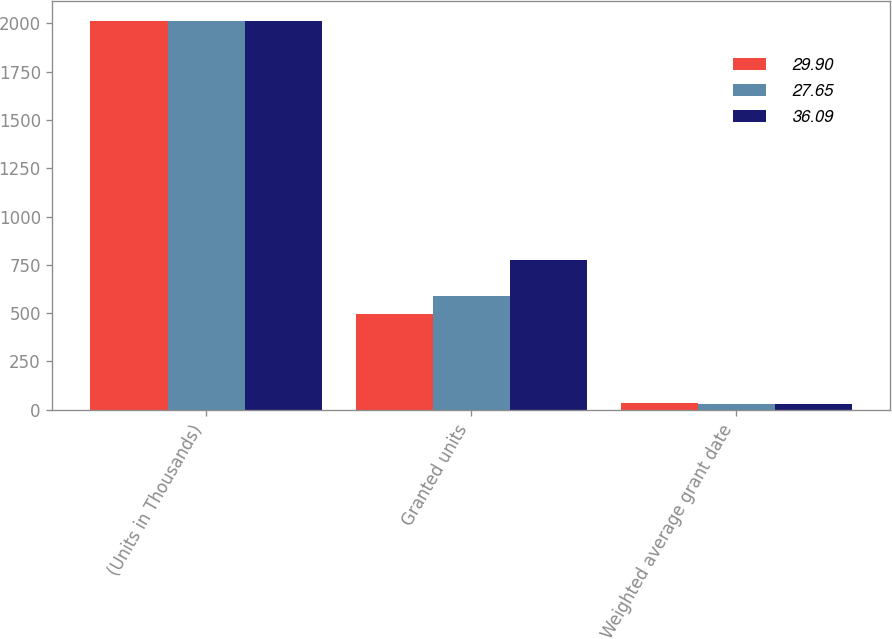Convert chart. <chart><loc_0><loc_0><loc_500><loc_500><stacked_bar_chart><ecel><fcel>(Units in Thousands)<fcel>Granted units<fcel>Weighted average grant date<nl><fcel>29.9<fcel>2015<fcel>496<fcel>36.09<nl><fcel>27.65<fcel>2014<fcel>588<fcel>29.9<nl><fcel>36.09<fcel>2013<fcel>774<fcel>27.65<nl></chart> 